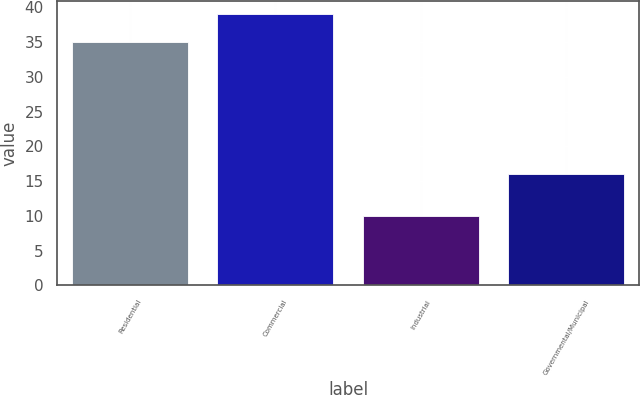Convert chart to OTSL. <chart><loc_0><loc_0><loc_500><loc_500><bar_chart><fcel>Residential<fcel>Commercial<fcel>Industrial<fcel>Governmental/Municipal<nl><fcel>35<fcel>39<fcel>10<fcel>16<nl></chart> 